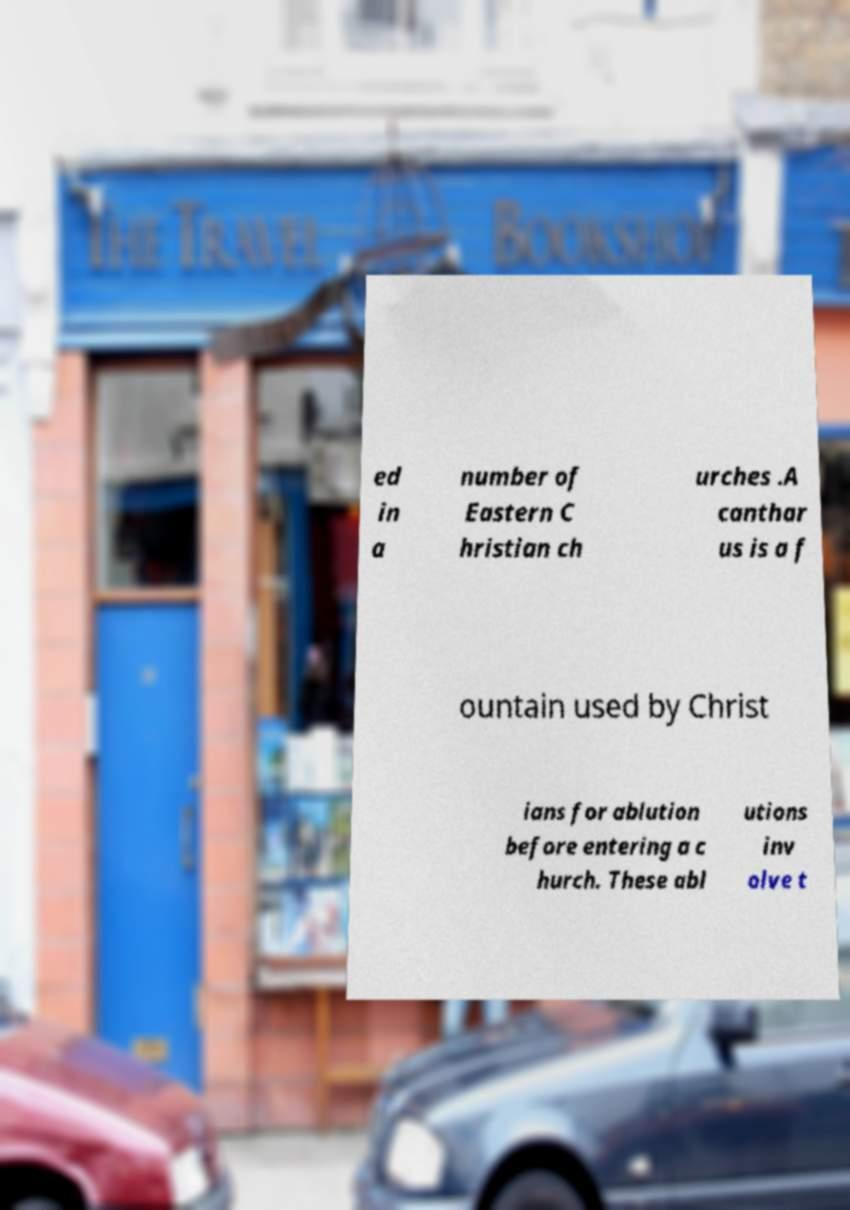There's text embedded in this image that I need extracted. Can you transcribe it verbatim? ed in a number of Eastern C hristian ch urches .A canthar us is a f ountain used by Christ ians for ablution before entering a c hurch. These abl utions inv olve t 